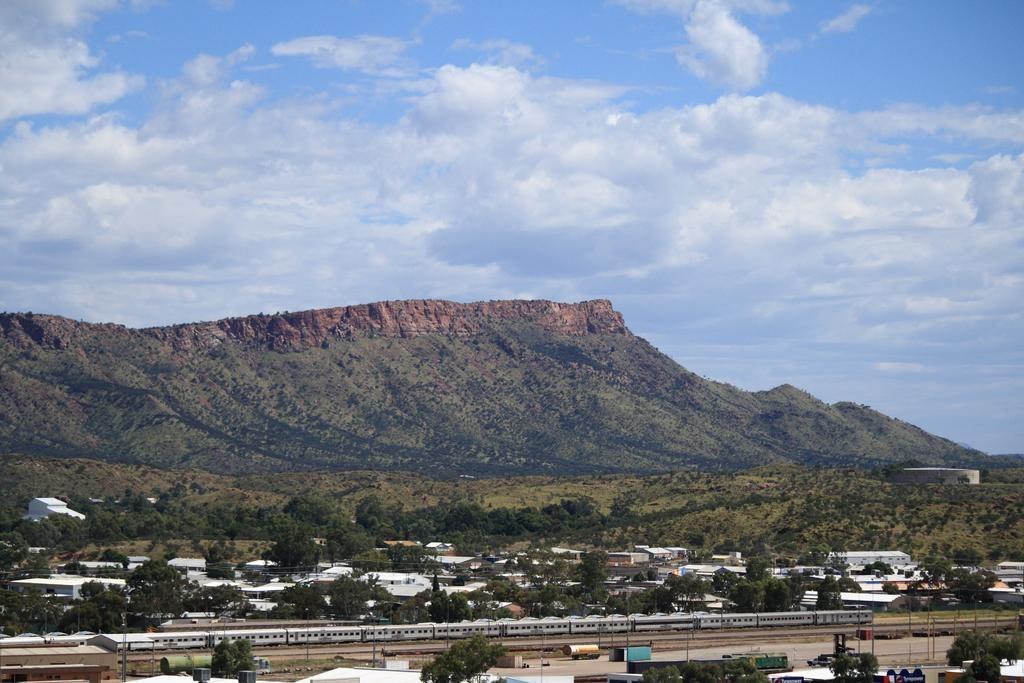What is the main subject of the image? There is a train in the image. What can be seen in the foreground of the image? There are many trees and buildings in the image. What is visible in the background of the image? Hills and the sky are visible in the background of the image. What is the condition of the sky in the image? Clouds are present in the sky. What type of fowl can be seen flying over the train in the image? There is no fowl visible in the image; it only features a train, trees, buildings, hills, and the sky. How many wheels are visible on the train in the image? The image does not show the wheels of the train, so it is not possible to determine the number of wheels. 